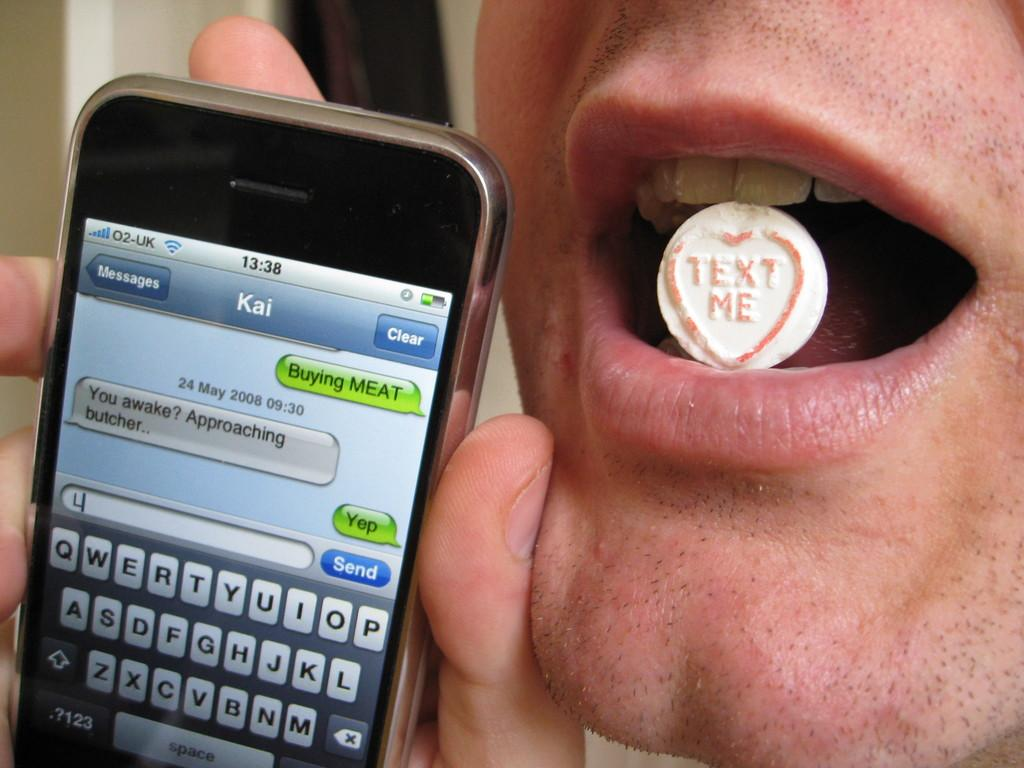<image>
Provide a brief description of the given image. A man with candy in his mouth that says Text me is holding a cell phone up. 